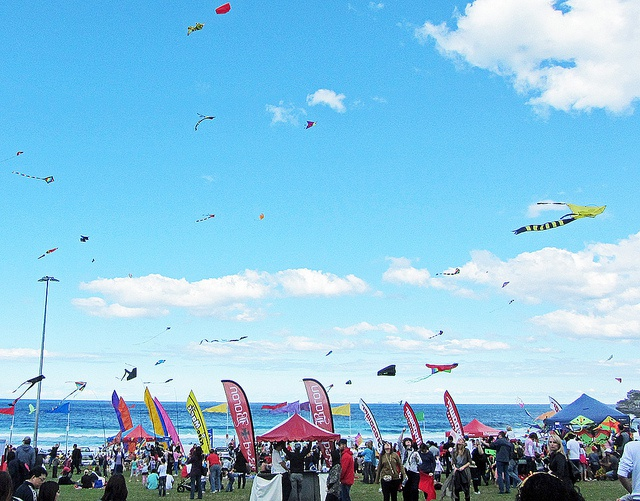Describe the objects in this image and their specific colors. I can see people in lightblue, black, gray, and lightgray tones, umbrella in lightblue, brown, maroon, and white tones, people in lightblue, black, gray, darkgray, and blue tones, umbrella in lightblue, gray, and blue tones, and people in lightblue, black, lightgray, gray, and darkgray tones in this image. 